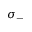<formula> <loc_0><loc_0><loc_500><loc_500>\sigma _ { - }</formula> 